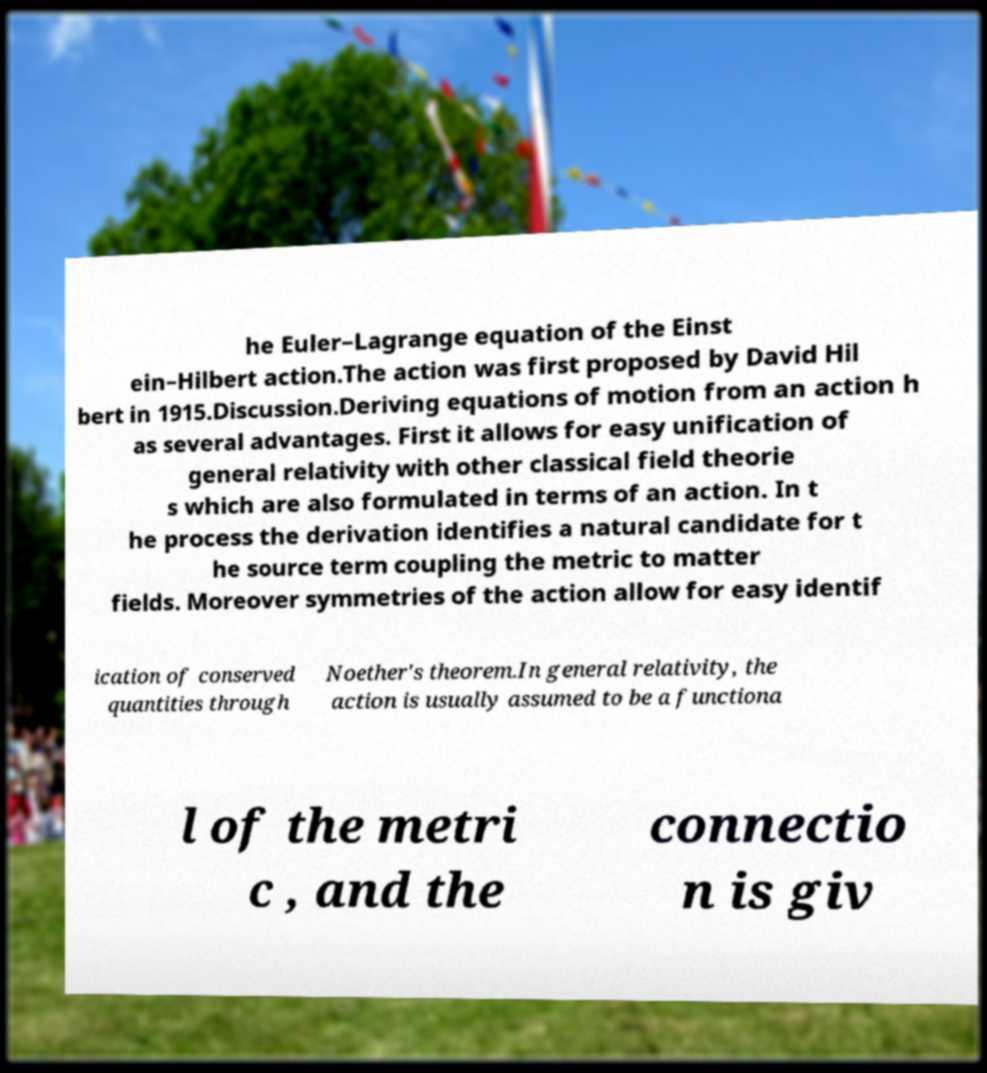What messages or text are displayed in this image? I need them in a readable, typed format. he Euler–Lagrange equation of the Einst ein–Hilbert action.The action was first proposed by David Hil bert in 1915.Discussion.Deriving equations of motion from an action h as several advantages. First it allows for easy unification of general relativity with other classical field theorie s which are also formulated in terms of an action. In t he process the derivation identifies a natural candidate for t he source term coupling the metric to matter fields. Moreover symmetries of the action allow for easy identif ication of conserved quantities through Noether's theorem.In general relativity, the action is usually assumed to be a functiona l of the metri c , and the connectio n is giv 